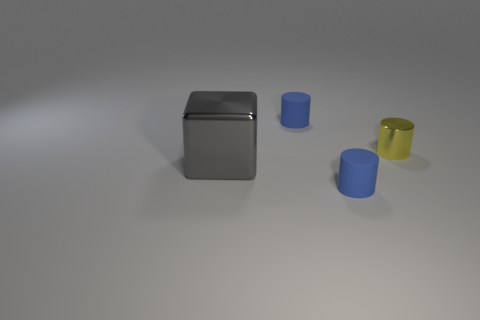Subtract all matte cylinders. How many cylinders are left? 1 Subtract all yellow cylinders. How many cylinders are left? 2 Add 3 large blocks. How many objects exist? 7 Subtract 2 cylinders. How many cylinders are left? 1 Subtract all green balls. How many purple cylinders are left? 0 Subtract all brown cylinders. Subtract all green spheres. How many cylinders are left? 3 Subtract all large gray objects. Subtract all blue matte cylinders. How many objects are left? 1 Add 3 small rubber cylinders. How many small rubber cylinders are left? 5 Add 3 gray objects. How many gray objects exist? 4 Subtract 0 green cylinders. How many objects are left? 4 